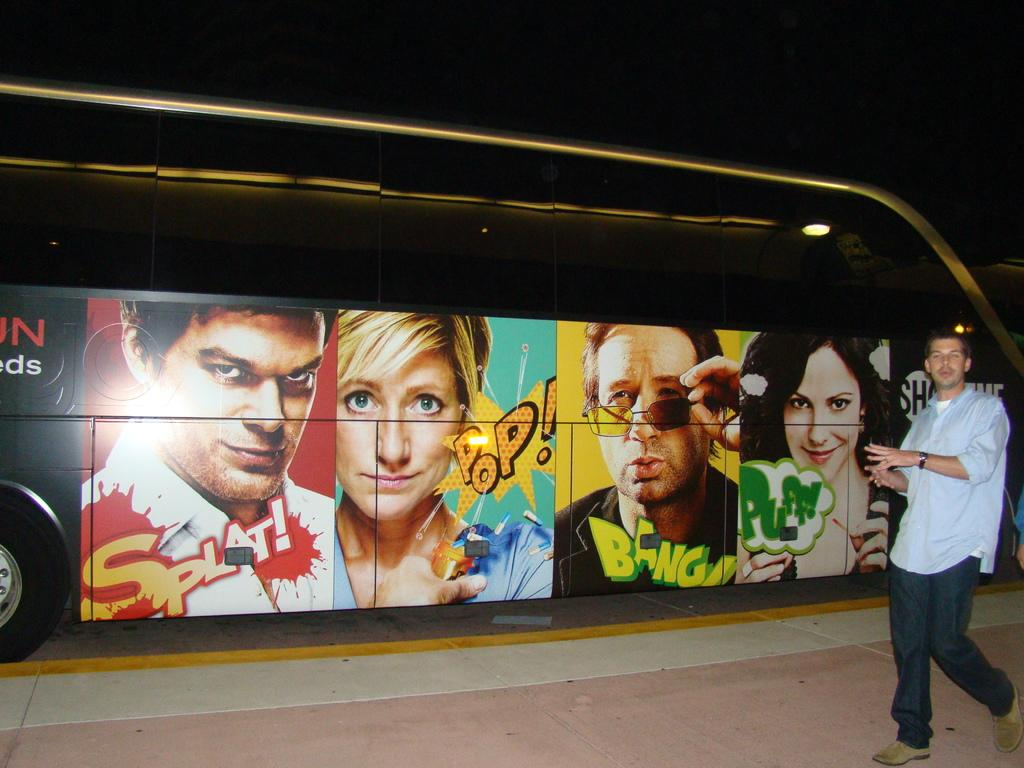What is the main subject of the image? There is a man in the image. What is the man doing in the image? The man is walking on the right side of the image. What type of clothing is the man wearing? The man is wearing a shirt, trousers, and shoes. What else can be seen in the image besides the man? There are images on a vehicle in the middle of the image. What type of news can be heard coming from the man in the image? There is no indication in the image that the man is delivering news, so it's not possible to determine what, if any, news might be heard. What type of giants can be seen in the image? There are no giants present in the image. 